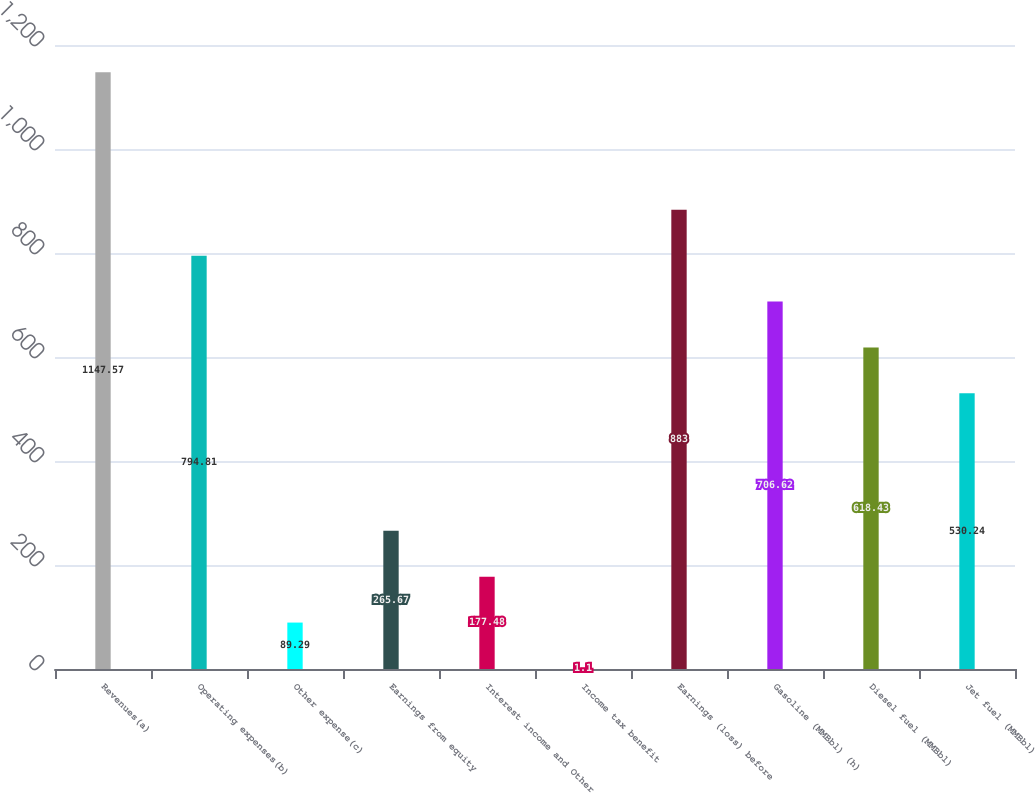<chart> <loc_0><loc_0><loc_500><loc_500><bar_chart><fcel>Revenues(a)<fcel>Operating expenses(b)<fcel>Other expense(c)<fcel>Earnings from equity<fcel>Interest income and Other<fcel>Income tax benefit<fcel>Earnings (loss) before<fcel>Gasoline (MMBbl) (h)<fcel>Diesel fuel (MMBbl)<fcel>Jet fuel (MMBbl)<nl><fcel>1147.57<fcel>794.81<fcel>89.29<fcel>265.67<fcel>177.48<fcel>1.1<fcel>883<fcel>706.62<fcel>618.43<fcel>530.24<nl></chart> 